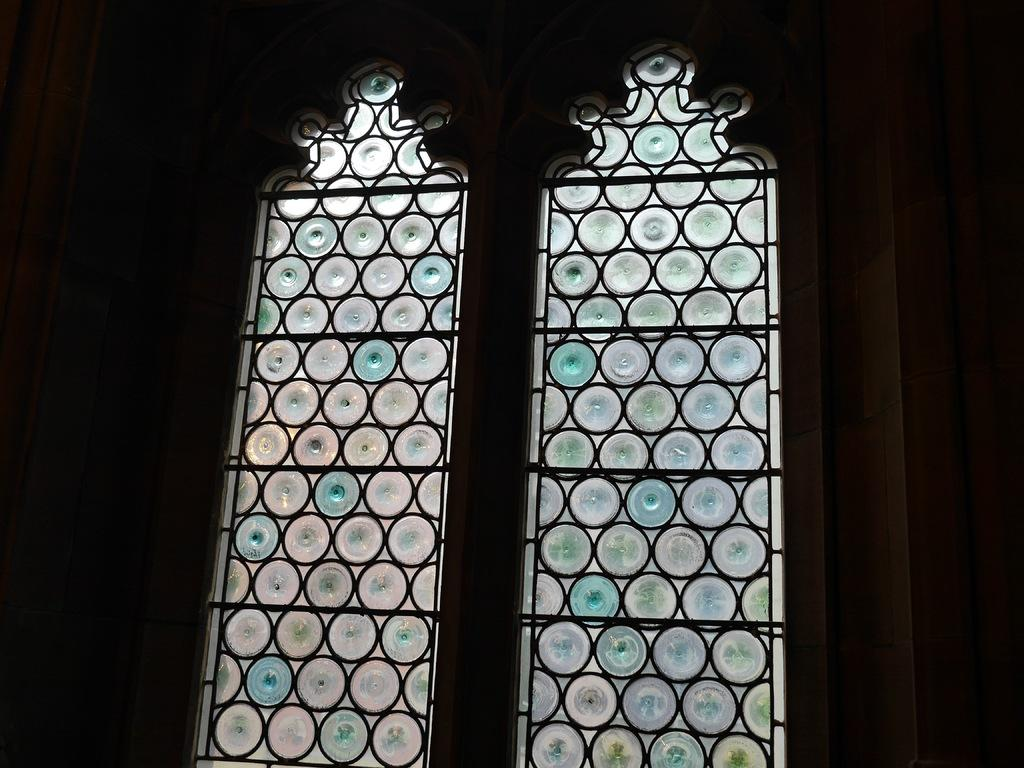What architectural feature can be seen in the image? There is a window, doors, and a wall in the image. How many doors are visible in the image? The image shows at least one door. What part of the image appears to be dark? The left side of the image appears to be dark. Can you see a squirrel running across the wall in the image? There is no squirrel present in the image. What belief system is being practiced by the people in the image? The image does not provide any information about the belief system of the people. 